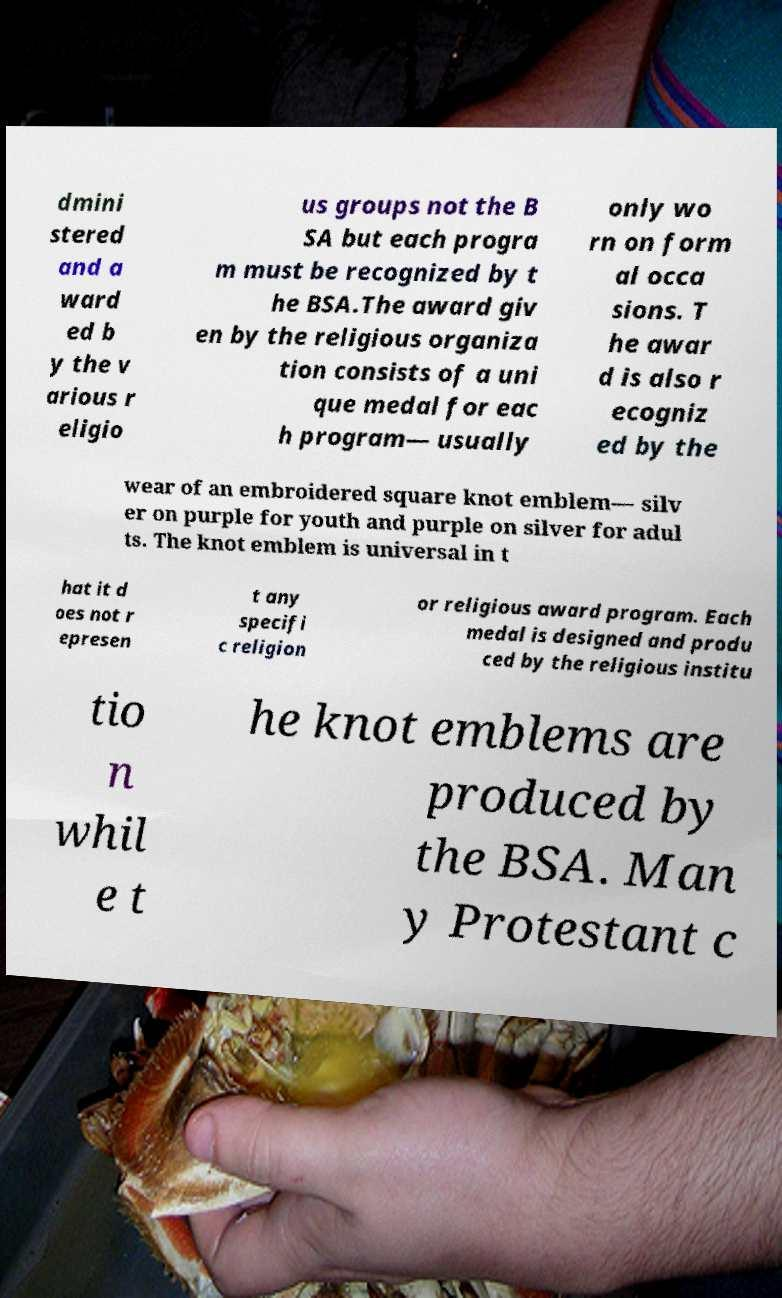Please read and relay the text visible in this image. What does it say? dmini stered and a ward ed b y the v arious r eligio us groups not the B SA but each progra m must be recognized by t he BSA.The award giv en by the religious organiza tion consists of a uni que medal for eac h program— usually only wo rn on form al occa sions. T he awar d is also r ecogniz ed by the wear of an embroidered square knot emblem— silv er on purple for youth and purple on silver for adul ts. The knot emblem is universal in t hat it d oes not r epresen t any specifi c religion or religious award program. Each medal is designed and produ ced by the religious institu tio n whil e t he knot emblems are produced by the BSA. Man y Protestant c 